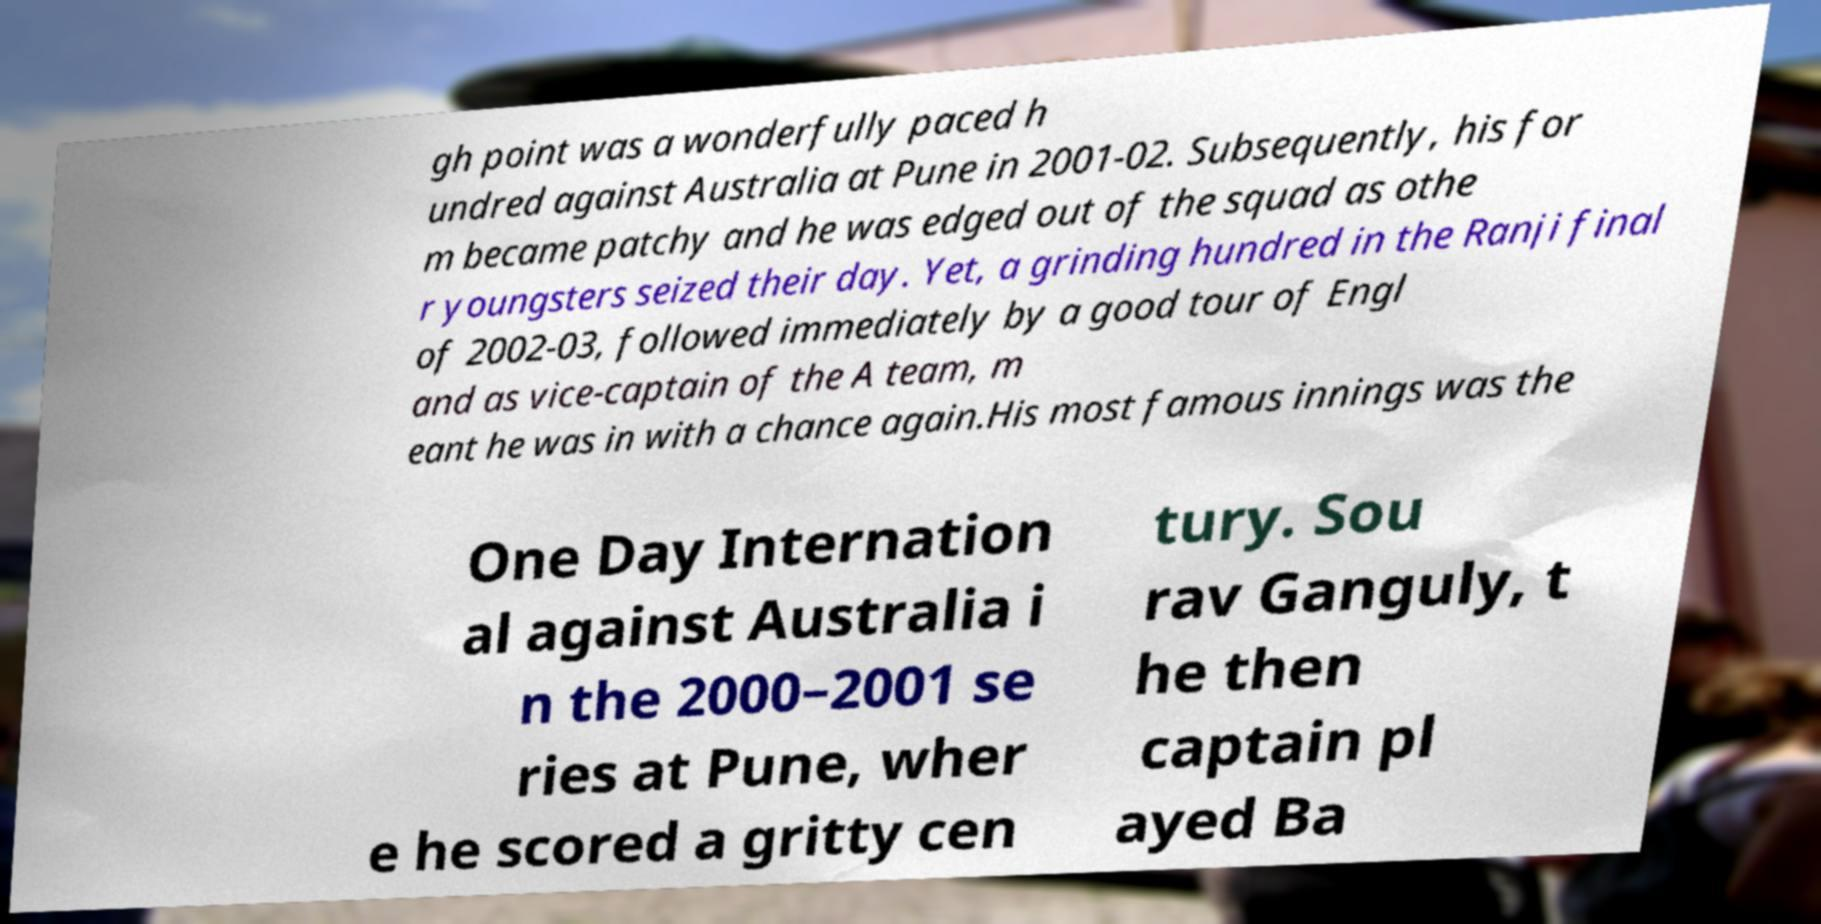Please read and relay the text visible in this image. What does it say? gh point was a wonderfully paced h undred against Australia at Pune in 2001-02. Subsequently, his for m became patchy and he was edged out of the squad as othe r youngsters seized their day. Yet, a grinding hundred in the Ranji final of 2002-03, followed immediately by a good tour of Engl and as vice-captain of the A team, m eant he was in with a chance again.His most famous innings was the One Day Internation al against Australia i n the 2000–2001 se ries at Pune, wher e he scored a gritty cen tury. Sou rav Ganguly, t he then captain pl ayed Ba 